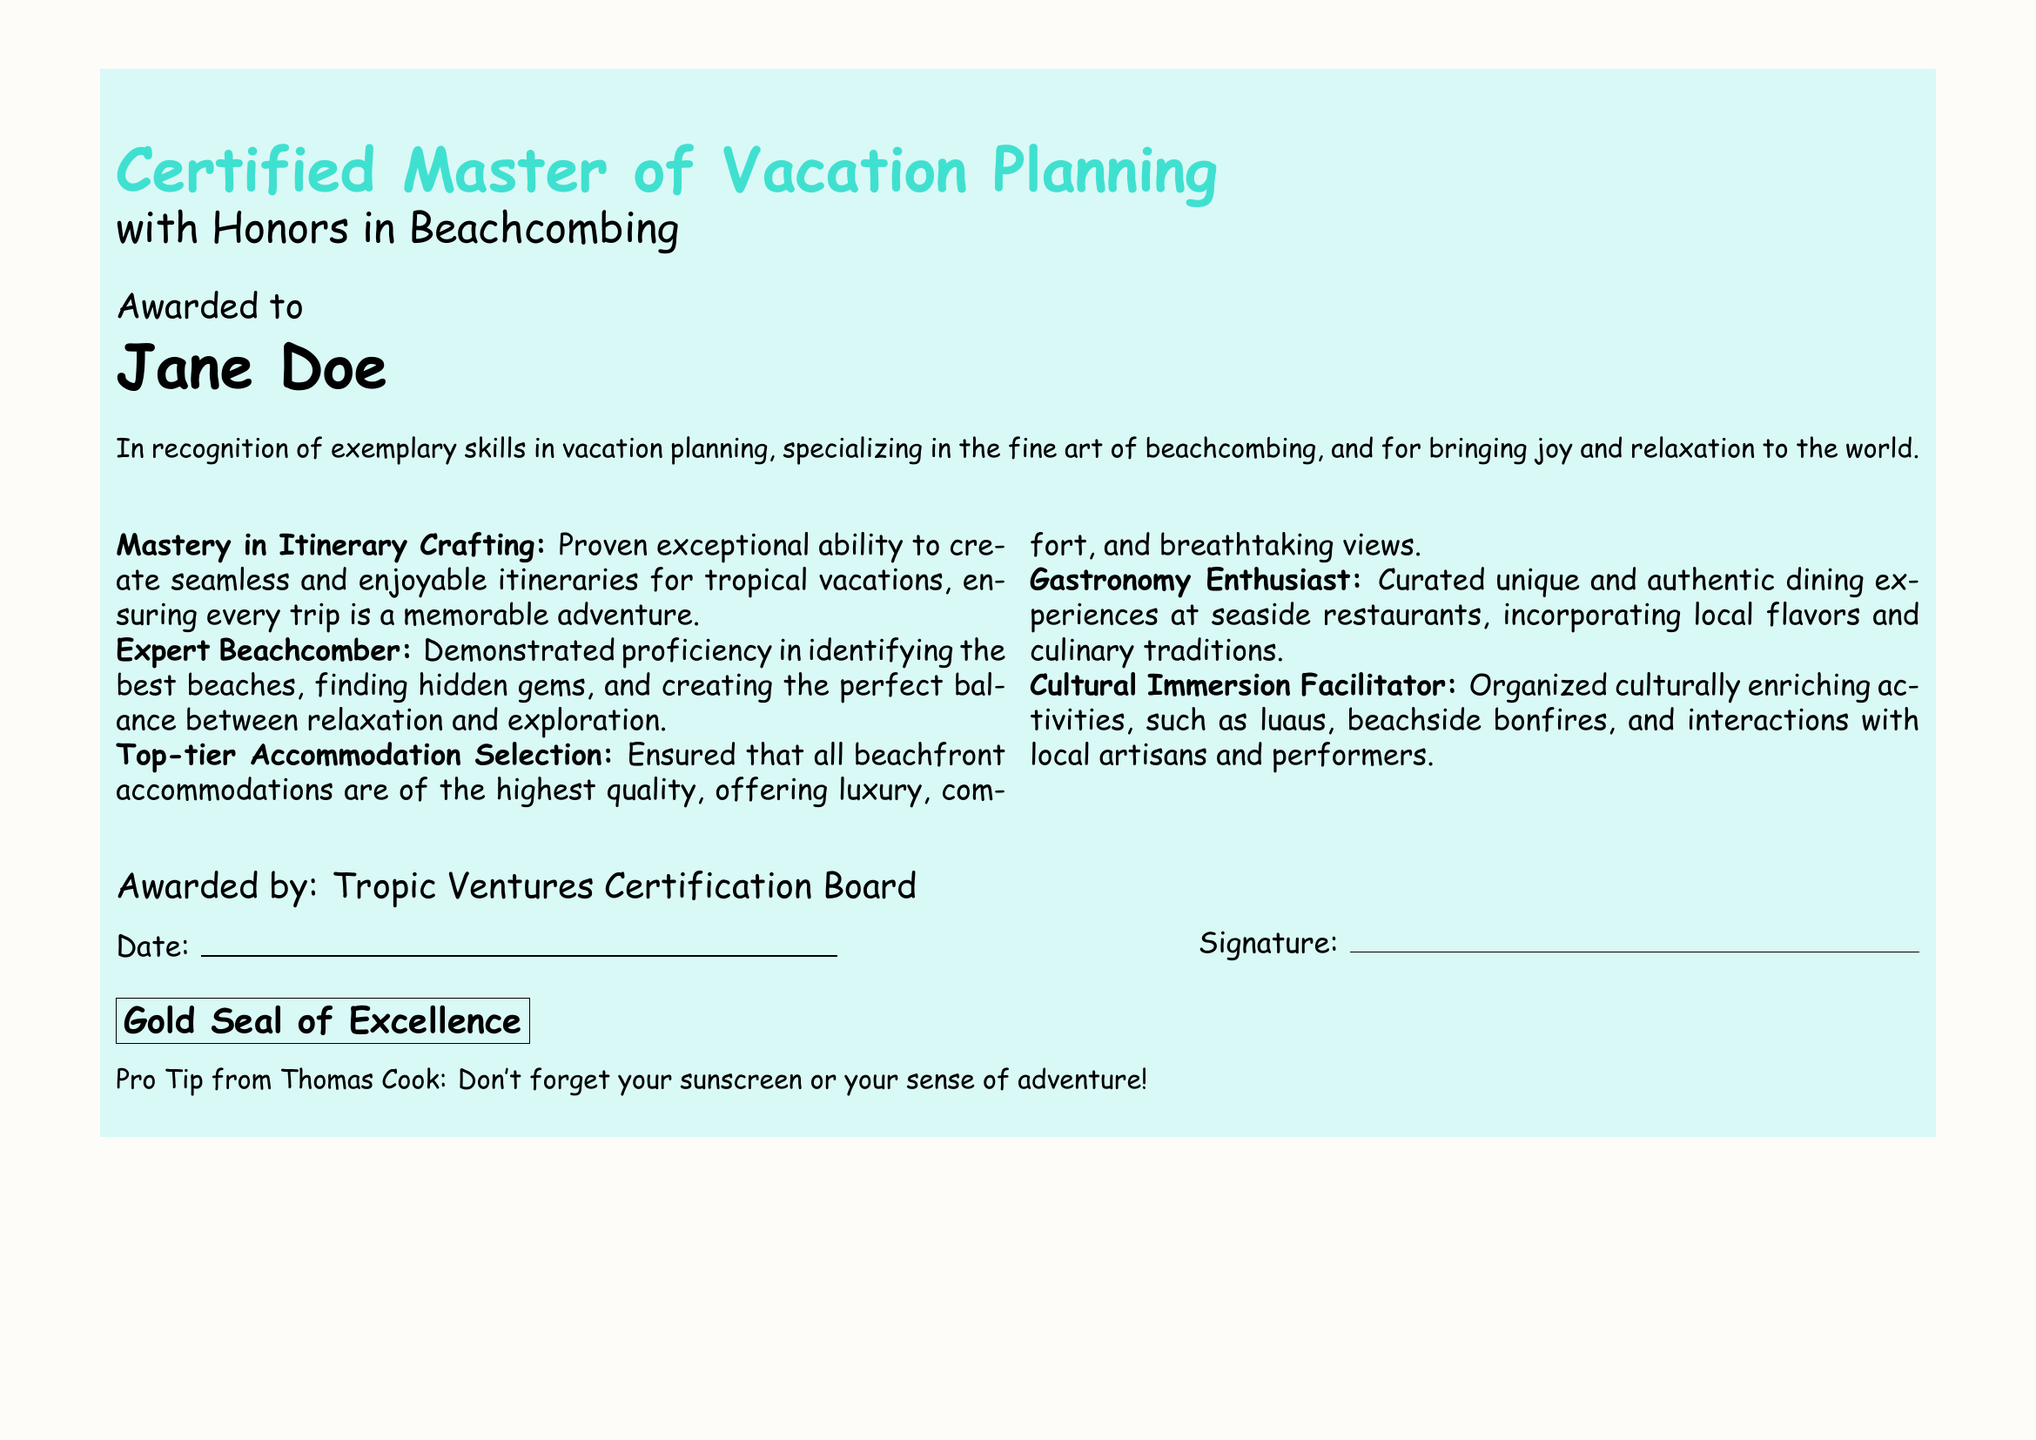What is the title of the certificate? The title of the certificate is displayed prominently at the top of the document.
Answer: Certified Master of Vacation Planning Who is the certificate awarded to? The name of the person receiving the certificate is stated below the title.
Answer: Jane Doe What is the specialization mentioned in the certificate? The specialization is indicated in the subtitle of the certificate.
Answer: Honors in Beachcombing What organization awarded the certificate? The issuer of the certificate is mentioned towards the bottom of the document.
Answer: Tropic Ventures Certification Board What feature is associated with the document's border? The document has a thematic design representative of its subject matter.
Answer: Tropical-themed borders How many achievements are listed in the document? By counting the achievements presented, we can find the total.
Answer: Five What date format is requested in the certificate? The document contains a space for a date, indicating its format.
Answer: Date: _________ What type of seal is mentioned in the document? There is a specific term used to describe the seal on the certificate.
Answer: Gold Seal of Excellence What humorous advice is given in the note at the bottom? The note provides a light-hearted tip related to vacationing.
Answer: Don't forget your sunscreen or your sense of adventure! What kind of experiences did the document suggest curating? The document highlights the type of dining experiences encouraged for travelers.
Answer: Unique and authentic dining experiences 